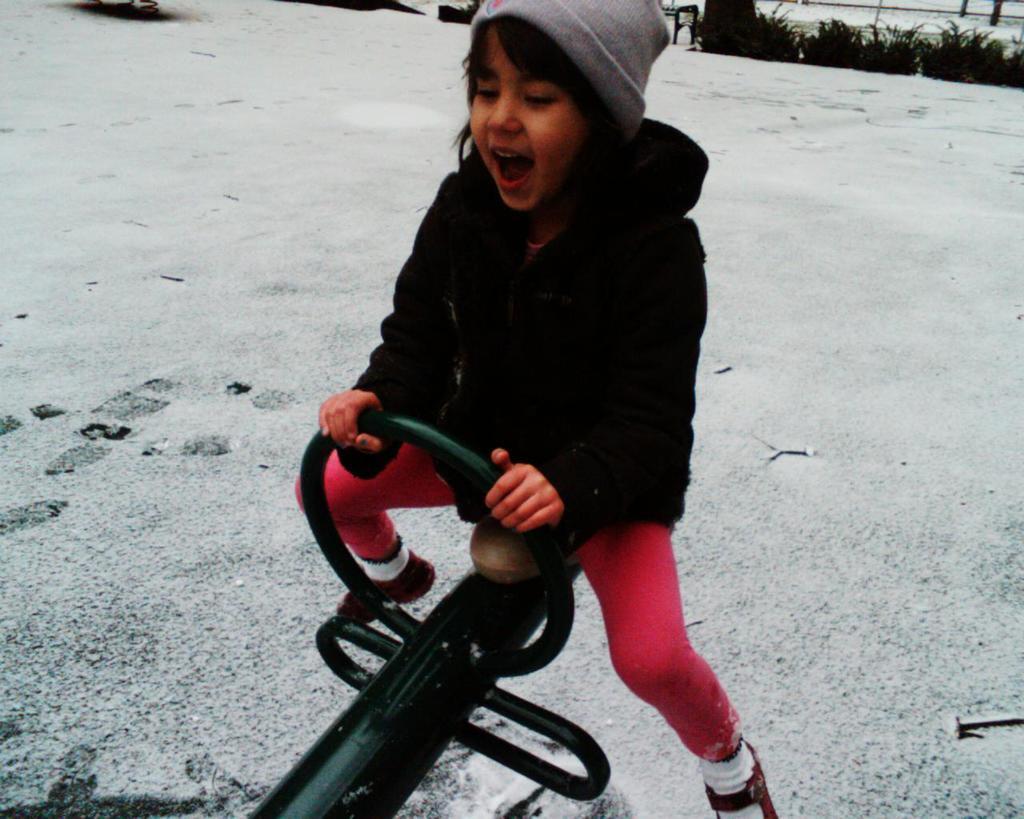In one or two sentences, can you explain what this image depicts? In this picture we can see a girl wore a jacket, cap and sitting on a seesaw and in the background we can see snow, trees. 